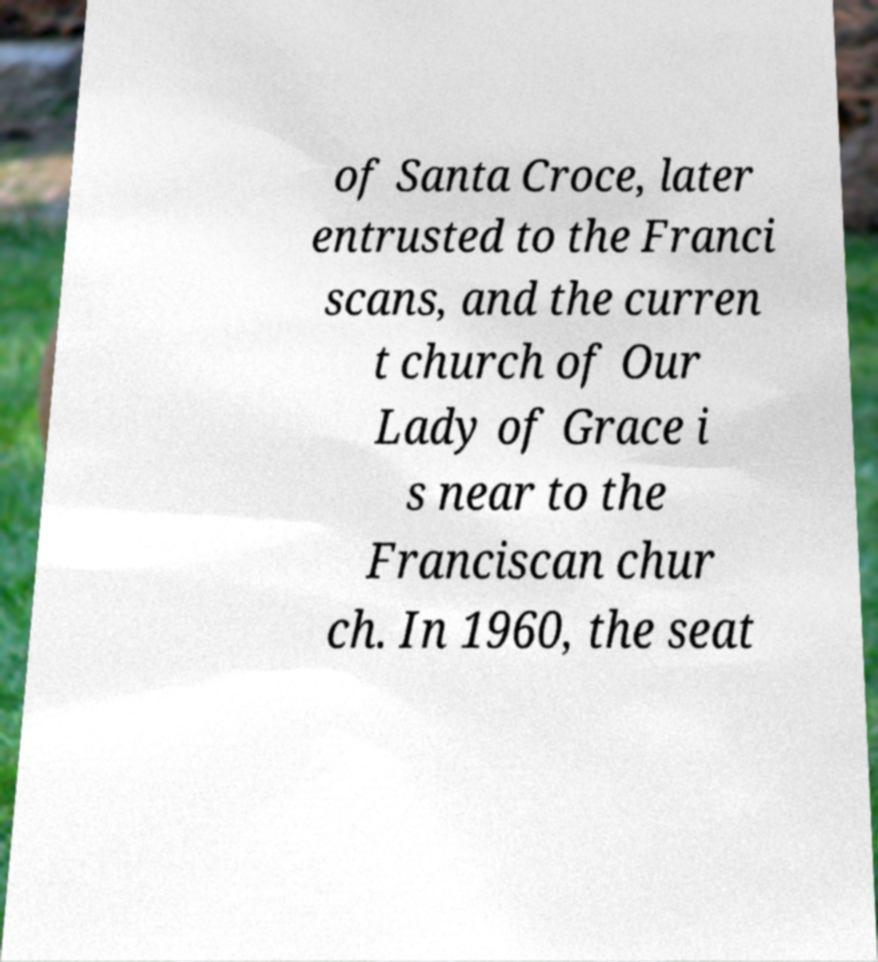What messages or text are displayed in this image? I need them in a readable, typed format. of Santa Croce, later entrusted to the Franci scans, and the curren t church of Our Lady of Grace i s near to the Franciscan chur ch. In 1960, the seat 